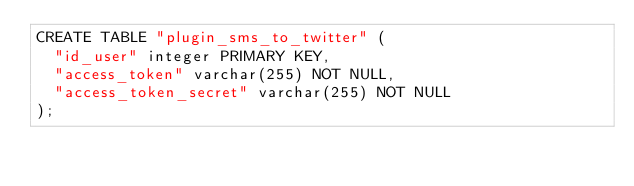Convert code to text. <code><loc_0><loc_0><loc_500><loc_500><_SQL_>CREATE TABLE "plugin_sms_to_twitter" (
	"id_user" integer PRIMARY KEY, 
	"access_token" varchar(255) NOT NULL, 
	"access_token_secret" varchar(255) NOT NULL
);</code> 